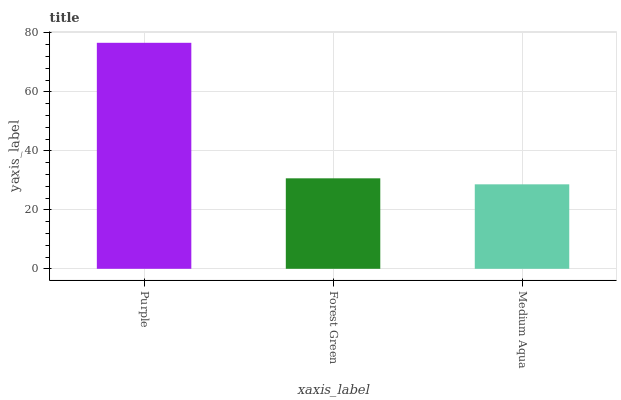Is Medium Aqua the minimum?
Answer yes or no. Yes. Is Purple the maximum?
Answer yes or no. Yes. Is Forest Green the minimum?
Answer yes or no. No. Is Forest Green the maximum?
Answer yes or no. No. Is Purple greater than Forest Green?
Answer yes or no. Yes. Is Forest Green less than Purple?
Answer yes or no. Yes. Is Forest Green greater than Purple?
Answer yes or no. No. Is Purple less than Forest Green?
Answer yes or no. No. Is Forest Green the high median?
Answer yes or no. Yes. Is Forest Green the low median?
Answer yes or no. Yes. Is Medium Aqua the high median?
Answer yes or no. No. Is Purple the low median?
Answer yes or no. No. 